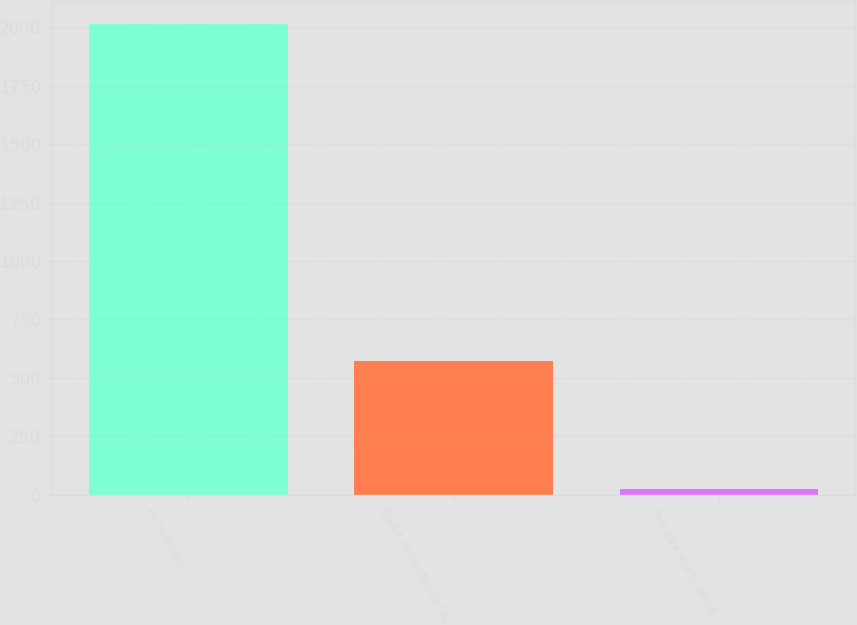Convert chart to OTSL. <chart><loc_0><loc_0><loc_500><loc_500><bar_chart><fcel>In millions<fcel>Debt reductions (a)<fcel>Pre-tax early debt<nl><fcel>2013<fcel>574<fcel>25<nl></chart> 